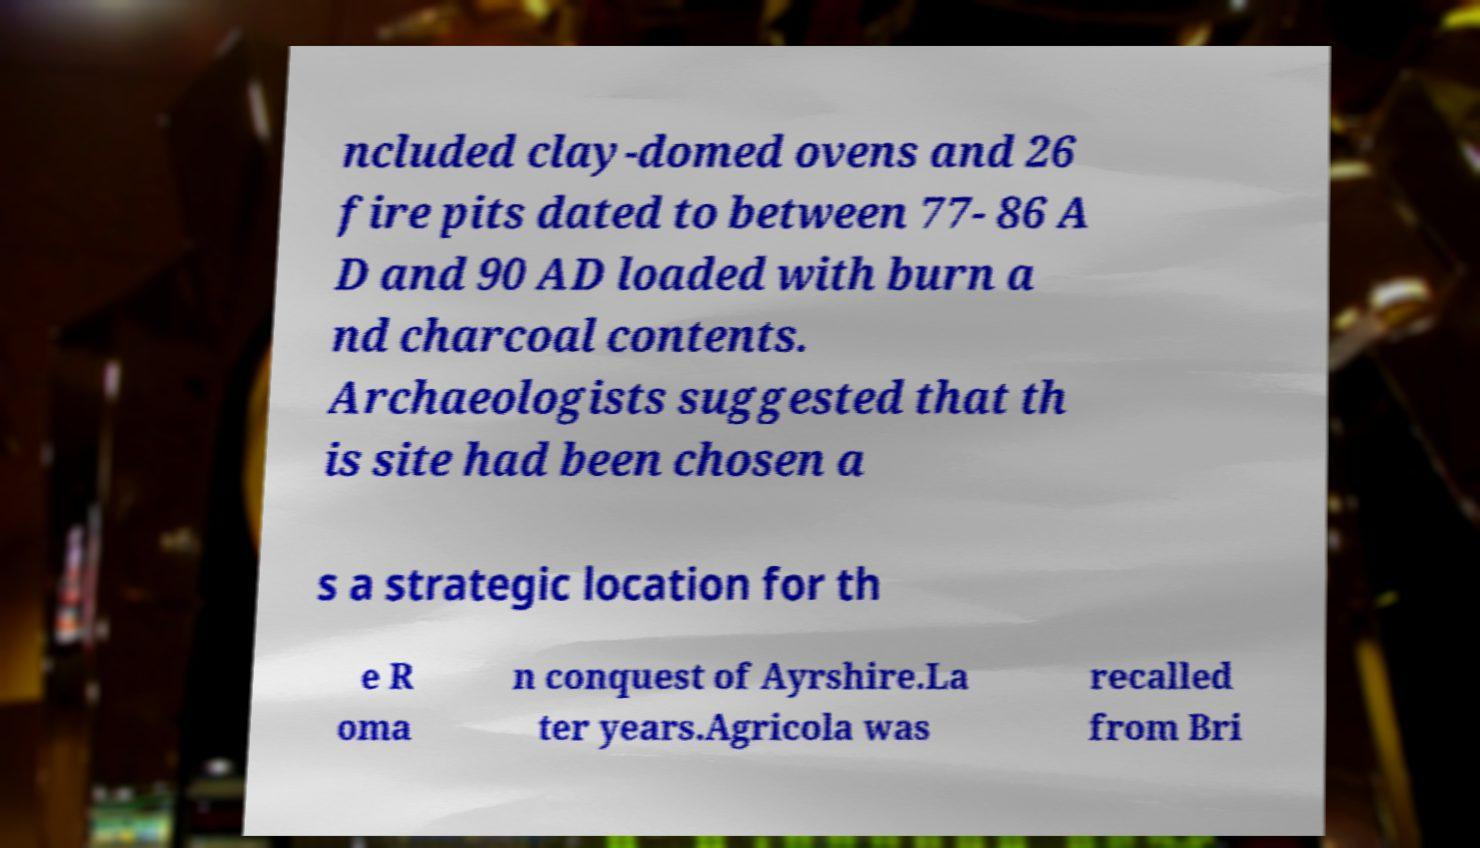Could you assist in decoding the text presented in this image and type it out clearly? ncluded clay-domed ovens and 26 fire pits dated to between 77- 86 A D and 90 AD loaded with burn a nd charcoal contents. Archaeologists suggested that th is site had been chosen a s a strategic location for th e R oma n conquest of Ayrshire.La ter years.Agricola was recalled from Bri 